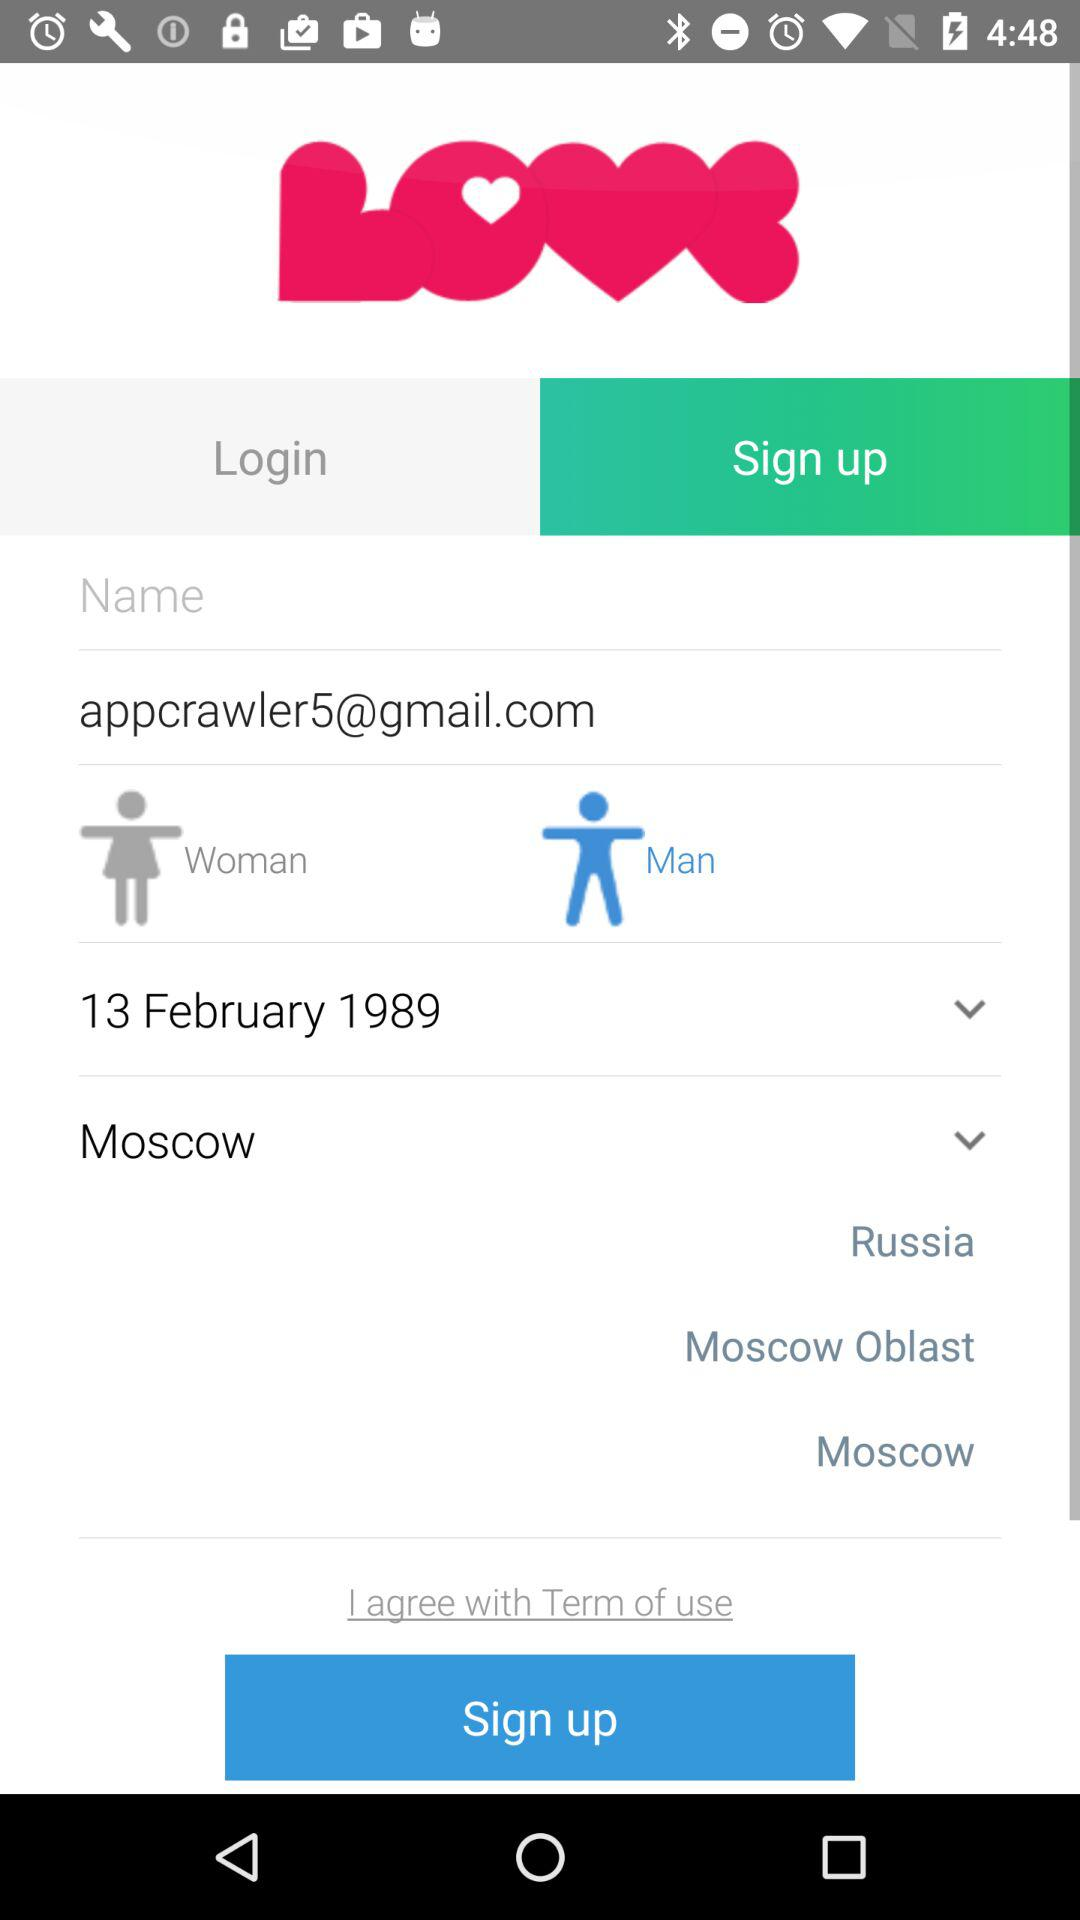What is the shown country? The shown country is Russia. 